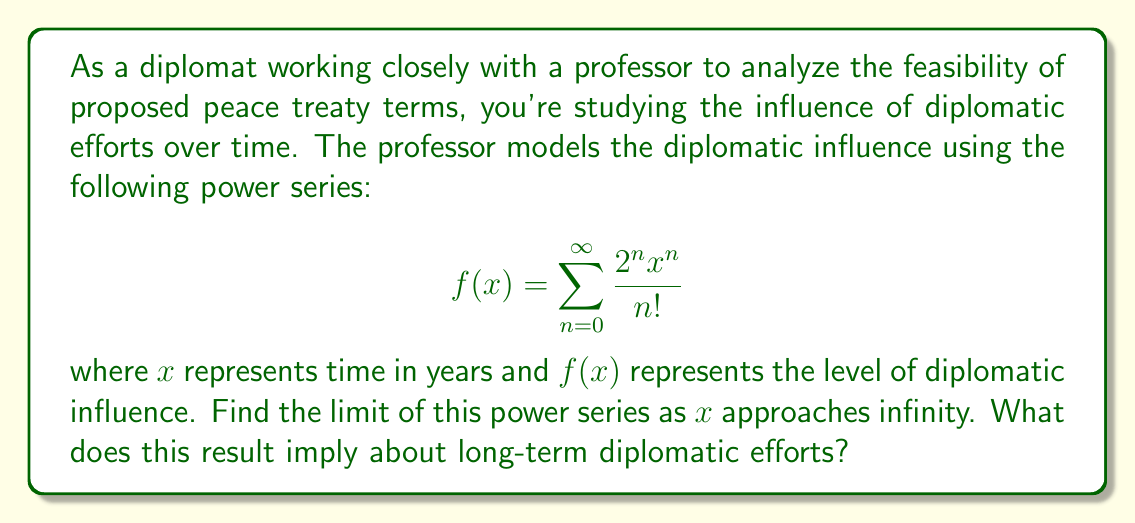Can you answer this question? To find the limit of this power series as $x$ approaches infinity, we can follow these steps:

1) First, recognize that this series resembles the Taylor series expansion of an exponential function. Specifically, it's similar to $e^x$, but with a base of 2 instead of $e$.

2) Let's rewrite the series in a more familiar form:

   $$f(x) = \sum_{n=0}^{\infty} \frac{(2x)^n}{n!}$$

3) This is exactly the Taylor series for $e^{2x}$. Therefore, we can say:

   $$f(x) = e^{2x}$$

4) Now, to find the limit as $x$ approaches infinity:

   $$\lim_{x \to \infty} f(x) = \lim_{x \to \infty} e^{2x}$$

5) As $x$ approaches infinity, $2x$ also approaches infinity, and $e$ raised to an increasingly large power approaches infinity.

6) Therefore:

   $$\lim_{x \to \infty} e^{2x} = \infty$$

This result implies that over a very long period, diplomatic influence as modeled by this function will grow without bound. In practical terms, this suggests that consistent diplomatic efforts over time can lead to ever-increasing influence, though real-world factors would likely introduce limitations not captured by this idealized model.
Answer: The limit of the power series $f(x) = \sum_{n=0}^{\infty} \frac{2^n x^n}{n!}$ as $x$ approaches infinity is $\infty$. 